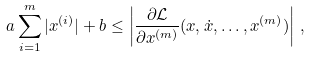Convert formula to latex. <formula><loc_0><loc_0><loc_500><loc_500>a \sum _ { i = 1 } ^ { m } | x ^ { ( i ) } | + b \leq \left | \frac { \partial \mathcal { L } } { \partial x ^ { ( m ) } } ( x , \dot { x } , \dots , x ^ { ( m ) } ) \right | \, ,</formula> 